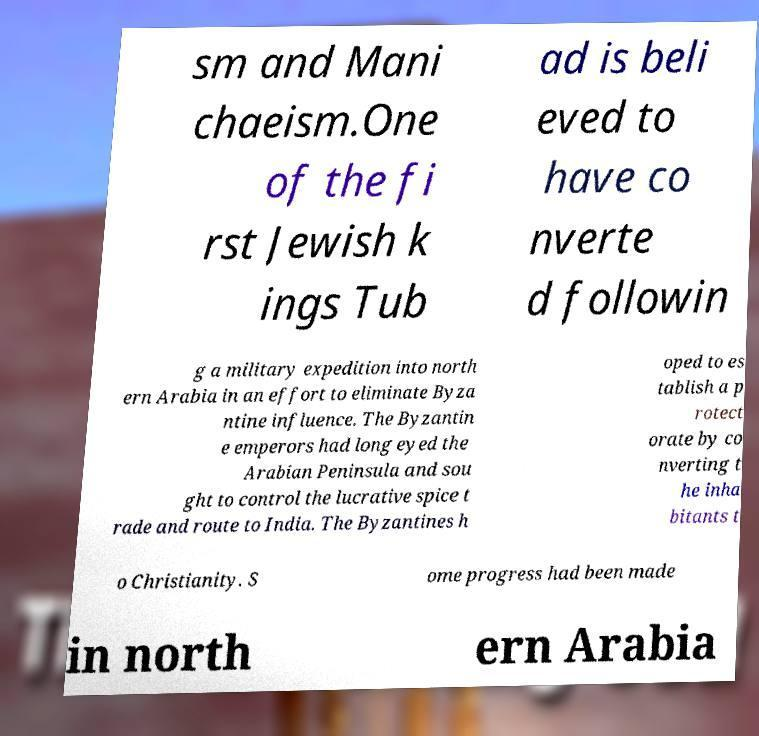What messages or text are displayed in this image? I need them in a readable, typed format. sm and Mani chaeism.One of the fi rst Jewish k ings Tub ad is beli eved to have co nverte d followin g a military expedition into north ern Arabia in an effort to eliminate Byza ntine influence. The Byzantin e emperors had long eyed the Arabian Peninsula and sou ght to control the lucrative spice t rade and route to India. The Byzantines h oped to es tablish a p rotect orate by co nverting t he inha bitants t o Christianity. S ome progress had been made in north ern Arabia 